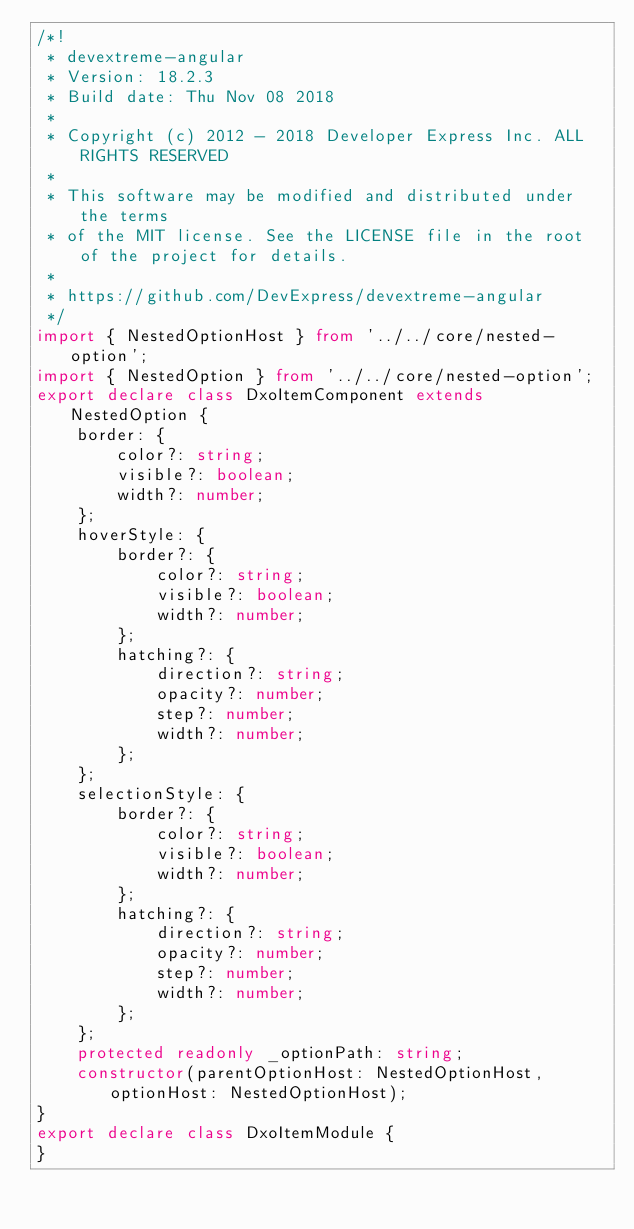Convert code to text. <code><loc_0><loc_0><loc_500><loc_500><_TypeScript_>/*!
 * devextreme-angular
 * Version: 18.2.3
 * Build date: Thu Nov 08 2018
 *
 * Copyright (c) 2012 - 2018 Developer Express Inc. ALL RIGHTS RESERVED
 *
 * This software may be modified and distributed under the terms
 * of the MIT license. See the LICENSE file in the root of the project for details.
 *
 * https://github.com/DevExpress/devextreme-angular
 */
import { NestedOptionHost } from '../../core/nested-option';
import { NestedOption } from '../../core/nested-option';
export declare class DxoItemComponent extends NestedOption {
    border: {
        color?: string;
        visible?: boolean;
        width?: number;
    };
    hoverStyle: {
        border?: {
            color?: string;
            visible?: boolean;
            width?: number;
        };
        hatching?: {
            direction?: string;
            opacity?: number;
            step?: number;
            width?: number;
        };
    };
    selectionStyle: {
        border?: {
            color?: string;
            visible?: boolean;
            width?: number;
        };
        hatching?: {
            direction?: string;
            opacity?: number;
            step?: number;
            width?: number;
        };
    };
    protected readonly _optionPath: string;
    constructor(parentOptionHost: NestedOptionHost, optionHost: NestedOptionHost);
}
export declare class DxoItemModule {
}
</code> 